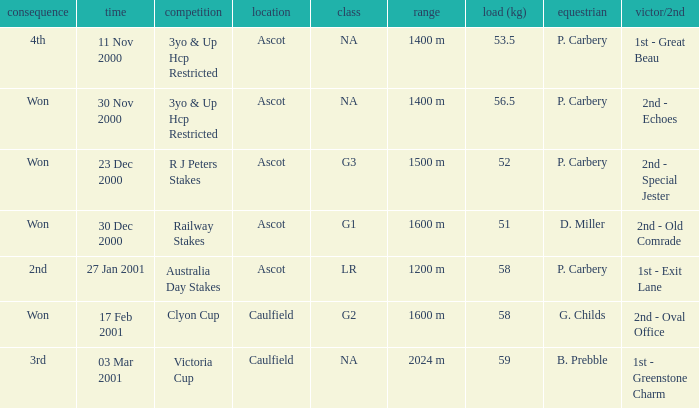What data is accessible for the group associated with a 56.5 kg weight? NA. 